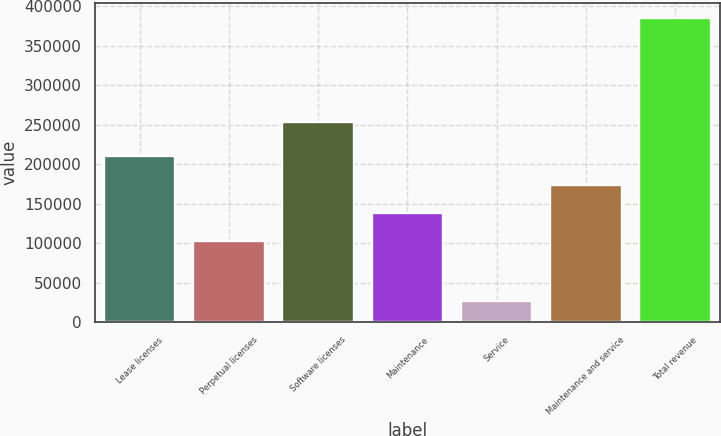Convert chart. <chart><loc_0><loc_0><loc_500><loc_500><bar_chart><fcel>Lease licenses<fcel>Perpetual licenses<fcel>Software licenses<fcel>Maintenance<fcel>Service<fcel>Maintenance and service<fcel>Total revenue<nl><fcel>210201<fcel>102733<fcel>253287<fcel>138556<fcel>27114<fcel>174378<fcel>385340<nl></chart> 